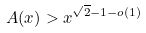Convert formula to latex. <formula><loc_0><loc_0><loc_500><loc_500>A ( x ) > x ^ { \sqrt { 2 } - 1 - o ( 1 ) }</formula> 